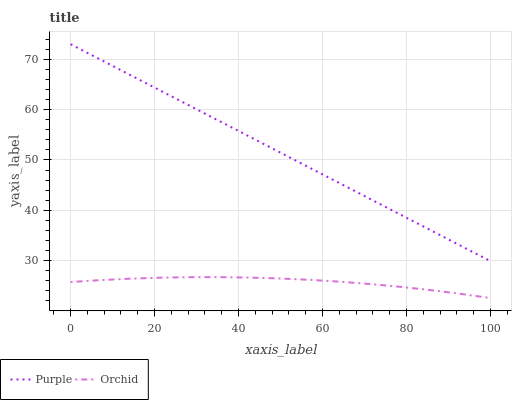Does Orchid have the minimum area under the curve?
Answer yes or no. Yes. Does Purple have the maximum area under the curve?
Answer yes or no. Yes. Does Orchid have the maximum area under the curve?
Answer yes or no. No. Is Purple the smoothest?
Answer yes or no. Yes. Is Orchid the roughest?
Answer yes or no. Yes. Is Orchid the smoothest?
Answer yes or no. No. Does Orchid have the lowest value?
Answer yes or no. Yes. Does Purple have the highest value?
Answer yes or no. Yes. Does Orchid have the highest value?
Answer yes or no. No. Is Orchid less than Purple?
Answer yes or no. Yes. Is Purple greater than Orchid?
Answer yes or no. Yes. Does Orchid intersect Purple?
Answer yes or no. No. 